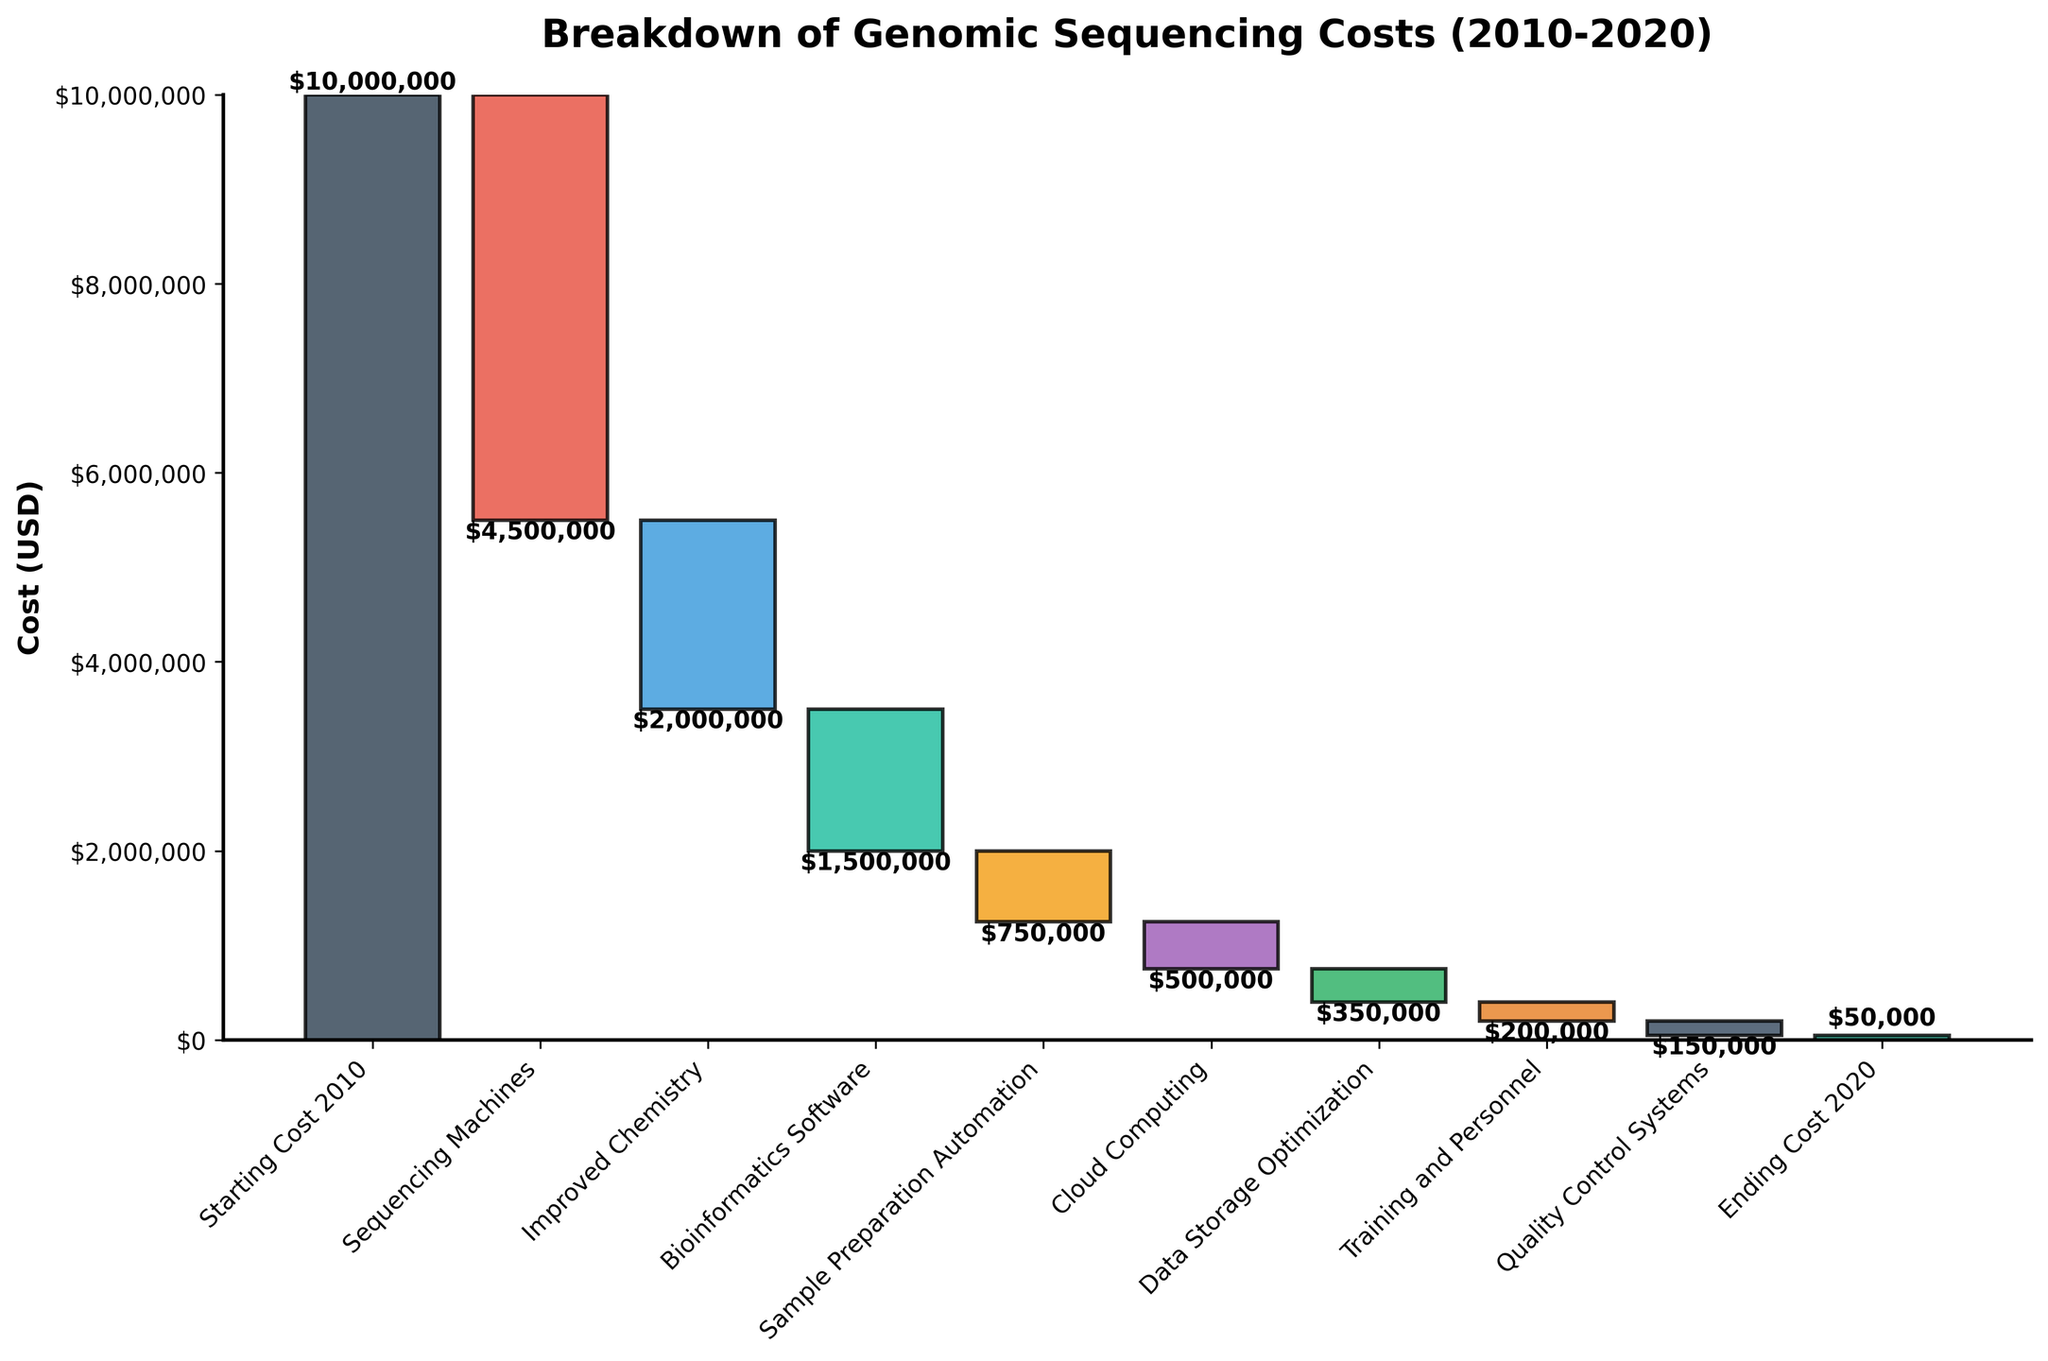What is the title of the figure? The title is typically placed at the top of the figure and clearly states what the figure is about.
Answer: Breakdown of Genomic Sequencing Costs (2010-2020) What is the starting cost of genomic sequencing in 2010? The starting cost in 2010 is represented by the first bar in the waterfall chart, labeled "Starting Cost 2010".
Answer: $10,000,000 Which category contributed the largest cost reduction? By comparing the height of each negative bar in the waterfall chart, we can see that "Sequencing Machines" contributed the largest cost reduction.
Answer: Sequencing Machines How much did improved chemistry lower the cost by? The bar for "Improved Chemistry" falls below the starting line, indicating a negative value. The number at the top/bottom of the bar represents the cost reduction.
Answer: $2,000,000 What is the ending cost of genomic sequencing in 2020? The ending cost for 2020 is shown by the last bar on the right, labeled "Ending Cost 2020".
Answer: $50,000 What is the total reduction in genomic sequencing costs from 2010 to 2020? The cumulative reduction is the difference between the starting cost in 2010 ($10,000,000) and the ending cost in 2020 ($50,000), which can be calculated as $10,000,000 - $50,000.
Answer: $9,950,000 Which improvements led to reductions of $1,000,000 or more? The categories with bars showing reductions equal to or greater than $1,000,000 are "Sequencing Machines," "Improved Chemistry," and "Bioinformatics Software."
Answer: Sequencing Machines, Improved Chemistry, Bioinformatics Software How did bioinformatics software impact the cost? The "Bioinformatics Software" bar is negative, indicating it contributed to reducing the cost. The exact impact is labeled on the bar as $1,500,000.
Answer: Reduced by $1,500,000 Which category had the smallest impact on reducing genomic sequencing costs? By comparing the heights of all the bars, the smallest negative bar is "Quality Control Systems."
Answer: Quality Control Systems What is the combined cost reduction from Cloud Computing and Data Storage Optimization? The cost reduction from "Cloud Computing" is $500,000 and from "Data Storage Optimization" is $350,000. Adding both gives $500,000 + $350,000.
Answer: $850,000 